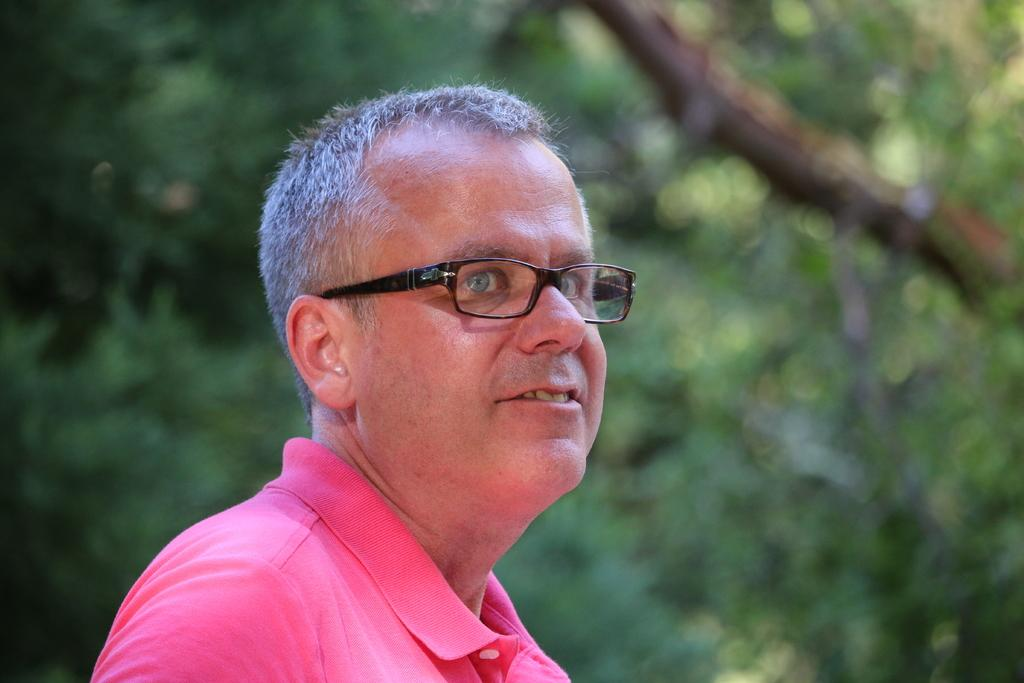Who is present in the image? There is a person in the image. What is the person wearing on their upper body? The person is wearing a pink t-shirt. What type of eyewear is the person wearing? The person is wearing black spectacles. What can be seen in the background of the image? There are trees in the background of the image. What type of treatment is the person receiving in the image? There is no indication in the image that the person is receiving any treatment. 